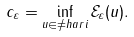Convert formula to latex. <formula><loc_0><loc_0><loc_500><loc_500>c _ { \varepsilon } = \inf _ { u \in \ne h a r i } \mathcal { E } _ { \varepsilon } ( u ) .</formula> 